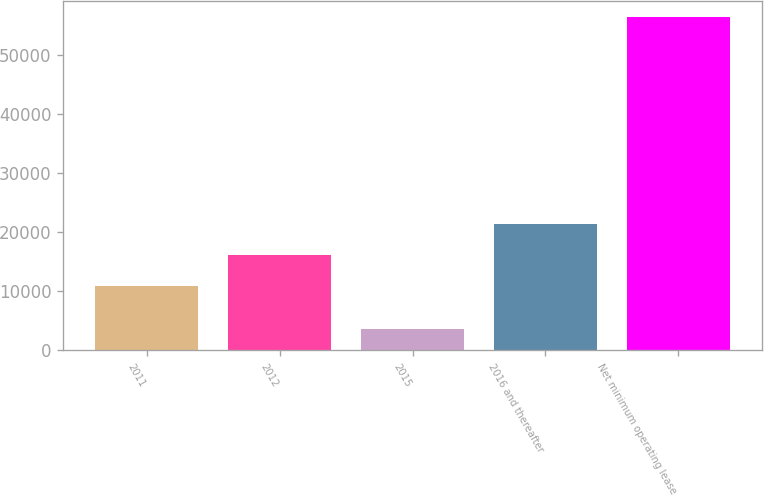Convert chart to OTSL. <chart><loc_0><loc_0><loc_500><loc_500><bar_chart><fcel>2011<fcel>2012<fcel>2015<fcel>2016 and thereafter<fcel>Net minimum operating lease<nl><fcel>10782<fcel>16069.4<fcel>3511<fcel>21356.8<fcel>56385<nl></chart> 